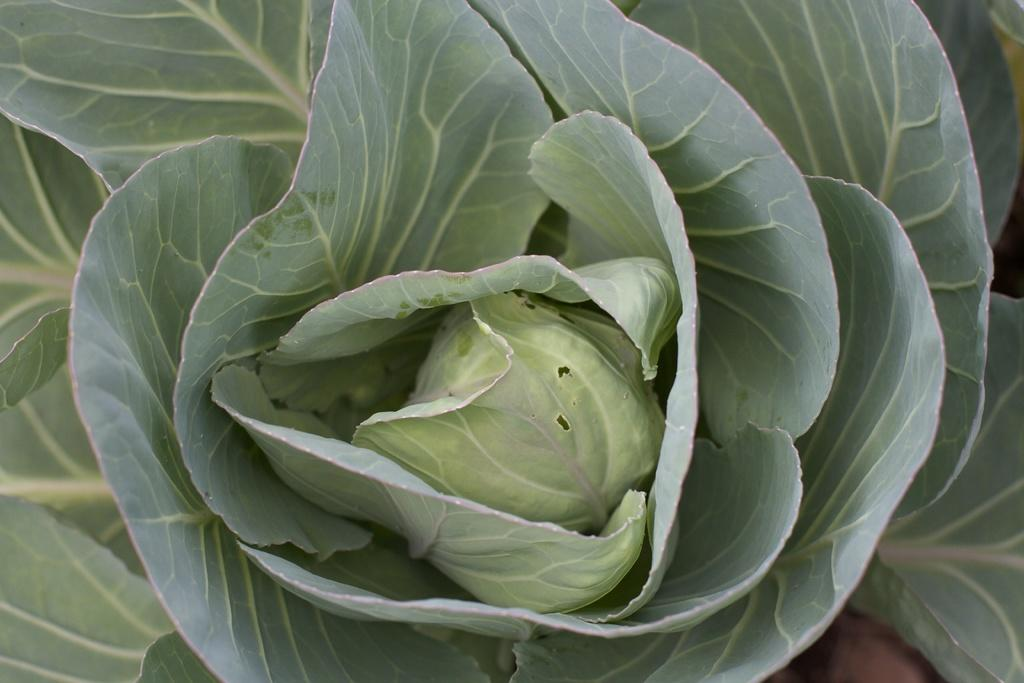What type of plants are in the image? There are spring greens in the image. What color are the spring greens? The spring greens are green in color. What type of chair is depicted in the image? There is no chair present in the image; it only features spring greens. Can you see the chin of the person holding the spring greens in the image? There is no person present in the image, so it is not possible to see their chin. 